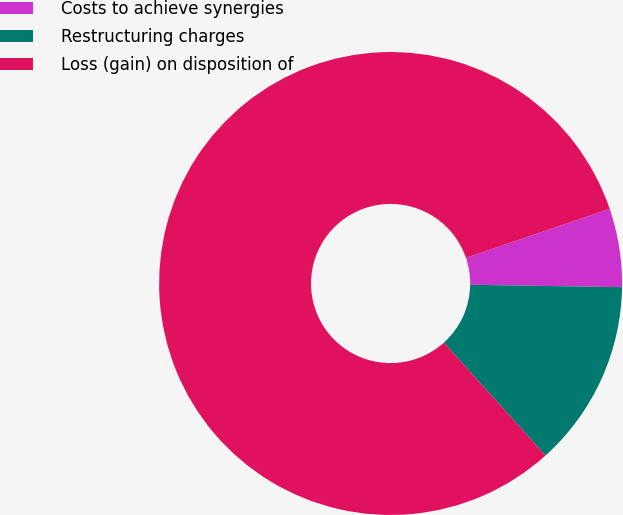Convert chart. <chart><loc_0><loc_0><loc_500><loc_500><pie_chart><fcel>Costs to achieve synergies<fcel>Restructuring charges<fcel>Loss (gain) on disposition of<nl><fcel>5.48%<fcel>13.08%<fcel>81.44%<nl></chart> 